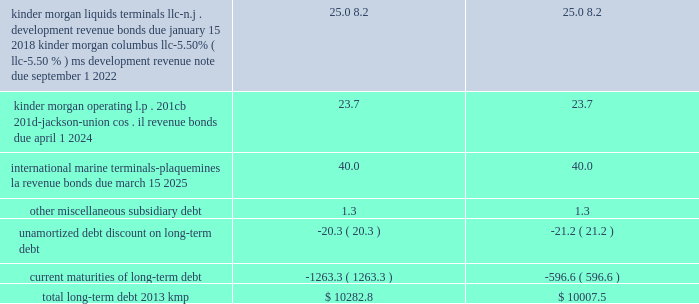Item 15 .
Exhibits , financial statement schedules .
( continued ) kinder morgan , inc .
Form 10-k .
____________ ( a ) as a result of the implementation of asu 2009-17 , effective january 1 , 2010 , we ( i ) include the transactions and balances of our business trust , k n capital trust i and k n capital trust iii , in our consolidated financial statements and ( ii ) no longer include our junior subordinated deferrable interest debentures issued to the capital trusts ( see note 18 201crecent accounting pronouncements 201d ) .
( b ) kmp issued its $ 500 million in principal amount of 9.00% ( 9.00 % ) senior notes due february 1 , 2019 in december 2008 .
Each holder of the notes has the right to require kmp to repurchase all or a portion of the notes owned by such holder on february 1 , 2012 at a purchase price equal to 100% ( 100 % ) of the principal amount of the notes tendered by the holder plus accrued and unpaid interest to , but excluding , the repurchase date .
On and after february 1 , 2012 , interest will cease to accrue on the notes tendered for repayment .
A holder 2019s exercise of the repurchase option is irrevocable .
Kinder morgan kansas , inc .
The 2028 and 2098 debentures and the 2012 and 2015 senior notes are redeemable in whole or in part , at kinder morgan kansas , inc . 2019s option at any time , at redemption prices defined in the associated prospectus supplements .
The 2027 debentures are redeemable in whole or in part , at kinder morgan kansas , inc . 2019s option after november 1 , 2004 at redemption prices defined in the associated prospectus supplements .
On september 2 , 2010 , kinder morgan kansas , inc .
Paid the remaining $ 1.1 million principal balance outstanding on kinder morgan kansas , inc . 2019s 6.50% ( 6.50 % ) series debentures , due 2013 .
Kinder morgan finance company , llc on december 20 , 2010 , kinder morgan finance company , llc , a wholly owned subsidiary of kinder morgan kansas , inc. , completed a public offering of senior notes .
It issued a total of $ 750 million in principal amount of 6.00% ( 6.00 % ) senior notes due january 15 , 2018 .
Net proceeds received from the issuance of the notes , after underwriting discounts and commissions , were $ 744.2 million , which were used to retire the principal amount of the 5.35% ( 5.35 % ) senior notes that matured on january 5 , 2011 .
The 2011 , 2016 , 2018 and 2036 senior notes issued by kinder morgan finance company , llc are redeemable in whole or in part , at kinder morgan kansas , inc . 2019s option at any time , at redemption prices defined in the associated prospectus supplements .
Each series of these notes is fully and unconditionally guaranteed by kinder morgan kansas , inc .
On a senior unsecured basis as to principal , interest and any additional amounts required to be paid as a result of any withholding or deduction for canadian taxes .
Capital trust securities kinder morgan kansas , inc . 2019s business trusts , k n capital trust i and k n capital trust iii , are obligated for $ 12.7 million of 8.56% ( 8.56 % ) capital trust securities maturing on april 15 , 2027 and $ 14.4 million of 7.63% ( 7.63 % ) capital trust securities maturing on april 15 , 2028 , respectively , which it guarantees .
The 2028 securities are redeemable in whole or in part , at kinder morgan kansas , inc . 2019s option at any time , at redemption prices as defined in the associated prospectus .
The 2027 securities are redeemable in whole or in part at kinder morgan kansas , inc . 2019s option and at any time in certain limited circumstances upon the occurrence of certain events and at prices , all defined in the associated prospectus supplements .
Upon redemption by kinder morgan kansas , inc .
Or at maturity of the junior subordinated deferrable interest debentures , it must use the proceeds to make redemptions of the capital trust securities on a pro rata basis. .
What is the aggregate , inclusive of current maturities of total long-term debt 2013 kmp after the implementation of asu 2009-17 is current maturities , in millions? 
Computations: (10282.8 + 1263.3)
Answer: 11546.1. 